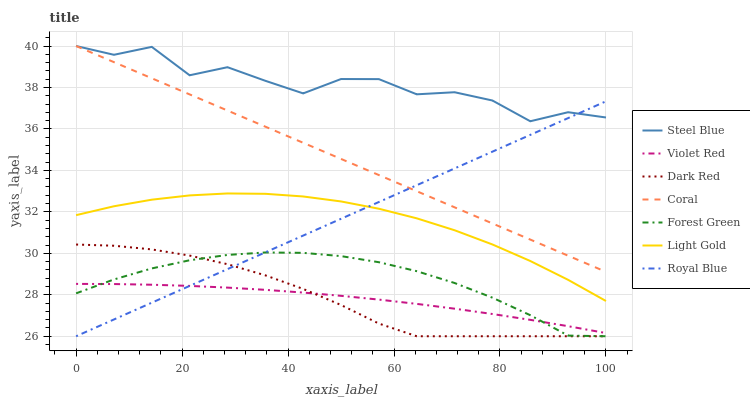Does Dark Red have the minimum area under the curve?
Answer yes or no. No. Does Dark Red have the maximum area under the curve?
Answer yes or no. No. Is Dark Red the smoothest?
Answer yes or no. No. Is Dark Red the roughest?
Answer yes or no. No. Does Coral have the lowest value?
Answer yes or no. No. Does Dark Red have the highest value?
Answer yes or no. No. Is Forest Green less than Light Gold?
Answer yes or no. Yes. Is Steel Blue greater than Violet Red?
Answer yes or no. Yes. Does Forest Green intersect Light Gold?
Answer yes or no. No. 